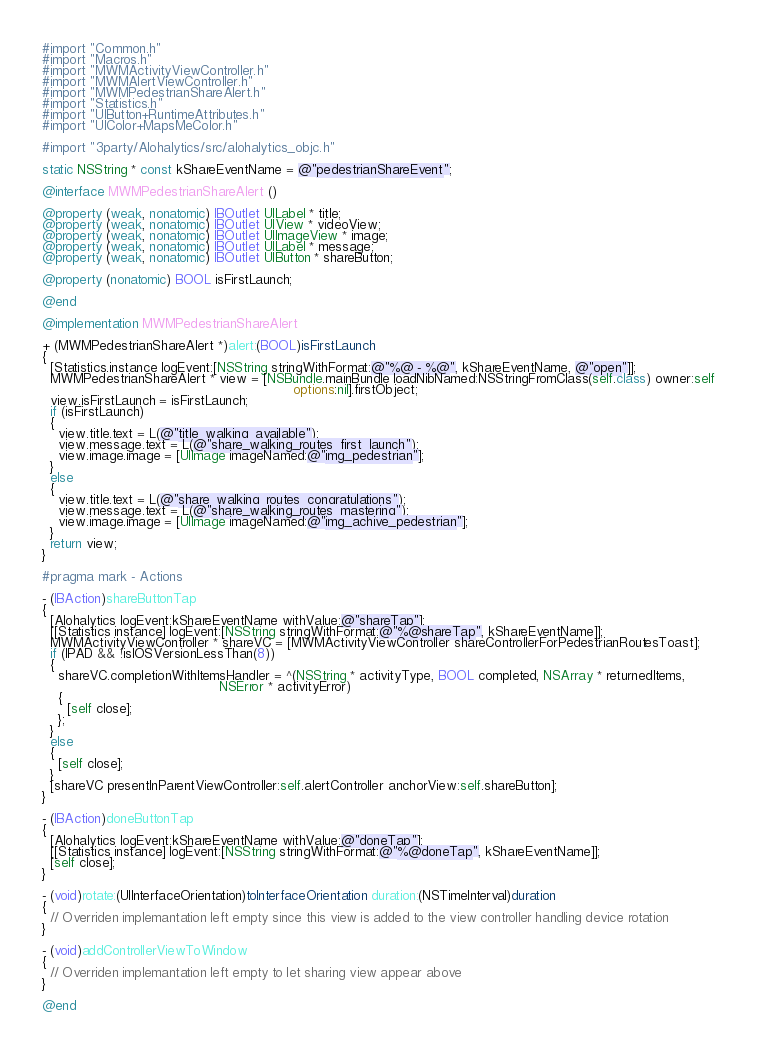<code> <loc_0><loc_0><loc_500><loc_500><_ObjectiveC_>#import "Common.h"
#import "Macros.h"
#import "MWMActivityViewController.h"
#import "MWMAlertViewController.h"
#import "MWMPedestrianShareAlert.h"
#import "Statistics.h"
#import "UIButton+RuntimeAttributes.h"
#import "UIColor+MapsMeColor.h"

#import "3party/Alohalytics/src/alohalytics_objc.h"

static NSString * const kShareEventName = @"pedestrianShareEvent";

@interface MWMPedestrianShareAlert ()

@property (weak, nonatomic) IBOutlet UILabel * title;
@property (weak, nonatomic) IBOutlet UIView * videoView;
@property (weak, nonatomic) IBOutlet UIImageView * image;
@property (weak, nonatomic) IBOutlet UILabel * message;
@property (weak, nonatomic) IBOutlet UIButton * shareButton;

@property (nonatomic) BOOL isFirstLaunch;

@end

@implementation MWMPedestrianShareAlert

+ (MWMPedestrianShareAlert *)alert:(BOOL)isFirstLaunch
{
  [Statistics.instance logEvent:[NSString stringWithFormat:@"%@ - %@", kShareEventName, @"open"]];
  MWMPedestrianShareAlert * view = [NSBundle.mainBundle loadNibNamed:NSStringFromClass(self.class) owner:self
                                                             options:nil].firstObject;
  view.isFirstLaunch = isFirstLaunch;
  if (isFirstLaunch)
  {
    view.title.text = L(@"title_walking_available");
    view.message.text = L(@"share_walking_routes_first_launch");
    view.image.image = [UIImage imageNamed:@"img_pedestrian"];
  }
  else
  {
    view.title.text = L(@"share_walking_routes_congratulations");
    view.message.text = L(@"share_walking_routes_mastering");
    view.image.image = [UIImage imageNamed:@"img_achive_pedestrian"];
  }
  return view;
}

#pragma mark - Actions

- (IBAction)shareButtonTap
{
  [Alohalytics logEvent:kShareEventName withValue:@"shareTap"];
  [[Statistics instance] logEvent:[NSString stringWithFormat:@"%@shareTap", kShareEventName]];
  MWMActivityViewController * shareVC = [MWMActivityViewController shareControllerForPedestrianRoutesToast];
  if (IPAD && !isIOSVersionLessThan(8))
  {
    shareVC.completionWithItemsHandler = ^(NSString * activityType, BOOL completed, NSArray * returnedItems,
                                           NSError * activityError)
    {
      [self close];
    };
  }
  else
  {
    [self close];
  }
  [shareVC presentInParentViewController:self.alertController anchorView:self.shareButton];
}

- (IBAction)doneButtonTap
{
  [Alohalytics logEvent:kShareEventName withValue:@"doneTap"];
  [[Statistics instance] logEvent:[NSString stringWithFormat:@"%@doneTap", kShareEventName]];
  [self close];
}

- (void)rotate:(UIInterfaceOrientation)toInterfaceOrientation duration:(NSTimeInterval)duration
{
  // Overriden implemantation left empty since this view is added to the view controller handling device rotation
}

- (void)addControllerViewToWindow
{
  // Overriden implemantation left empty to let sharing view appear above
}

@end
</code> 